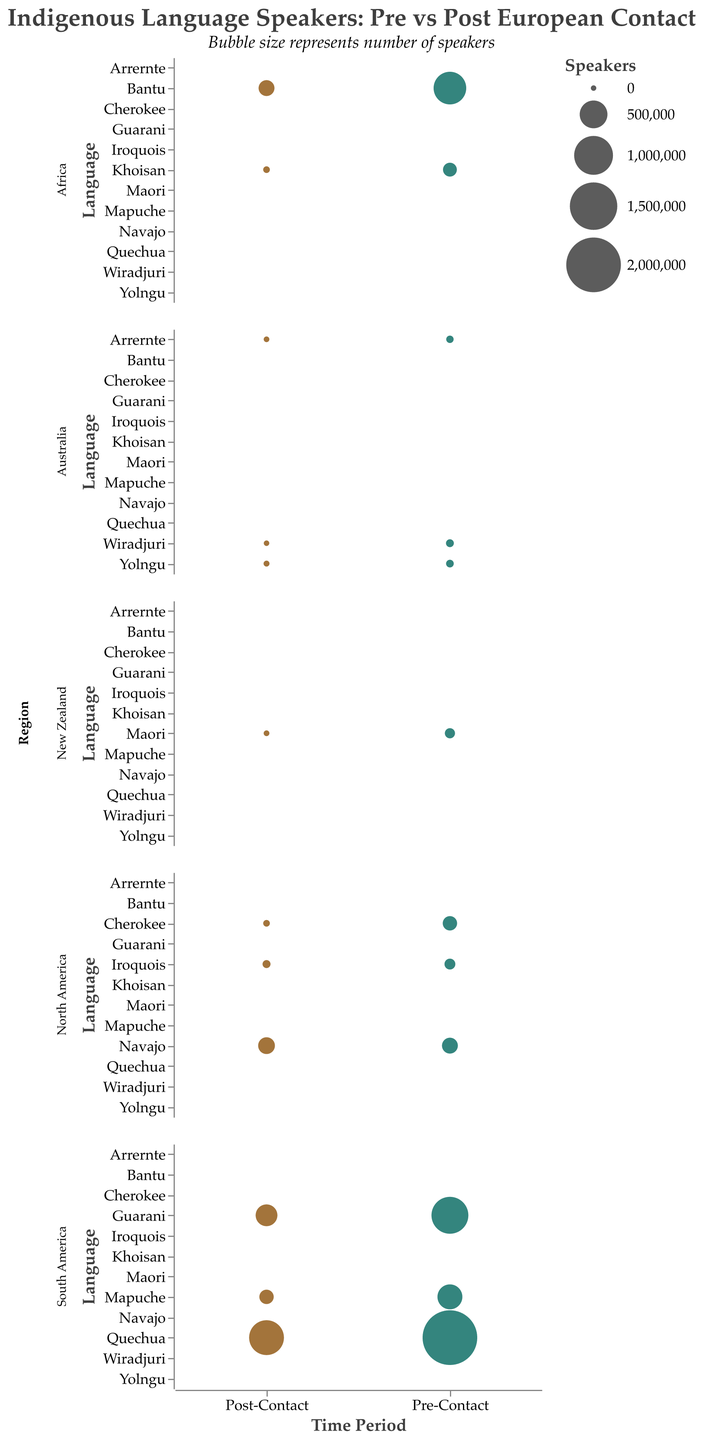Which region has the highest pre-contact frequency of speakers for an indigenous language? By examining the largest bubbles in the "Pre-Contact" time period across all regions, we find that the largest bubble is in the "South America" subplot for the Quechua language, indicating the highest frequency.
Answer: South America Which language in North America shows an increase in the number of speakers post-contact? Looking at the "North America" subplot and comparing pre-contact and post-contact bubble sizes for each language, we see that only Navajo shows an increase in frequency from 150,000 to 170,000 speakers.
Answer: Navajo What is the total post-contact frequency of indigenous languages spoken in Australia? Summing up the frequencies for "Arrernte" (1,500), "Yolngu" (3,500), and "Wiradjuri" (300) in the "Australia" subplot during the "Post-Contact" time period gives us 1,500 + 3,500 + 300 = 5,300.
Answer: 5,300 How does the post-contact frequency of the Guarani language compare to the pre-contact frequency within South America? In the "South America" subplot, the pre-contact frequency of Guarani is 900,000 and the post-contact frequency is 300,000. The difference is 900,000 - 300,000 = 600,000, showing a decrease.
Answer: Decreased by 600,000 What trend do you see regarding the frequency of indigenous languages in New Zealand pre and post European contact? The "New Zealand" subplot shows a significant decrease in frequency; the bubble size for Maori drops from 50,000 pre-contact to 2,000 post-contact.
Answer: Decreasing trend Which language has the smallest number of speakers post-contact in Africa? The "Africa" subplot shows two languages, Khoisan and Bantu, with post-contact frequencies of 10,000 and 150,000 respectively. The smaller post-contact frequency is for Khoisan.
Answer: Khoisan How many languages in South America had their number of speakers reduced post-contact? In the "South America" subplot, all examined languages (Quechua, Guarani, and Mapuche) show a reduction in the frequency of speakers post-contact.
Answer: 3 By what percentage did the frequency of Mapuche speakers in South America change post-contact? The pre-contact frequency for Mapuche is 400,000, and the post-contact frequency is 120,000. The percentage change is calculated as ((400,000 - 120,000) / 400,000) * 100 = 70%.
Answer: Reduced by 70% Which region shows the most significant decrease in indigenous language speakers post European contact? The comparison of bubble sizes across regions, pre- and post-contact, shows that South America experienced the most significant decrease for Quechua and Guarani languages, with high initial frequencies and substantial reductions.
Answer: South America 